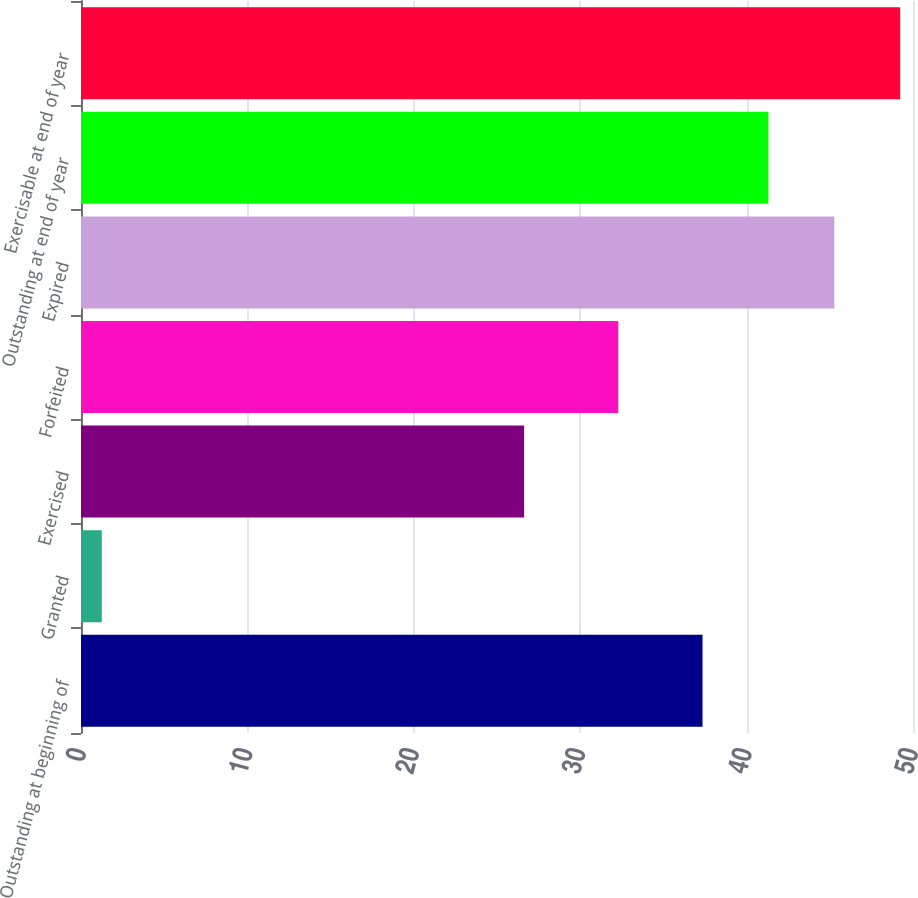Convert chart. <chart><loc_0><loc_0><loc_500><loc_500><bar_chart><fcel>Outstanding at beginning of<fcel>Granted<fcel>Exercised<fcel>Forfeited<fcel>Expired<fcel>Outstanding at end of year<fcel>Exercisable at end of year<nl><fcel>37.35<fcel>1.25<fcel>26.63<fcel>32.29<fcel>45.27<fcel>41.31<fcel>49.23<nl></chart> 